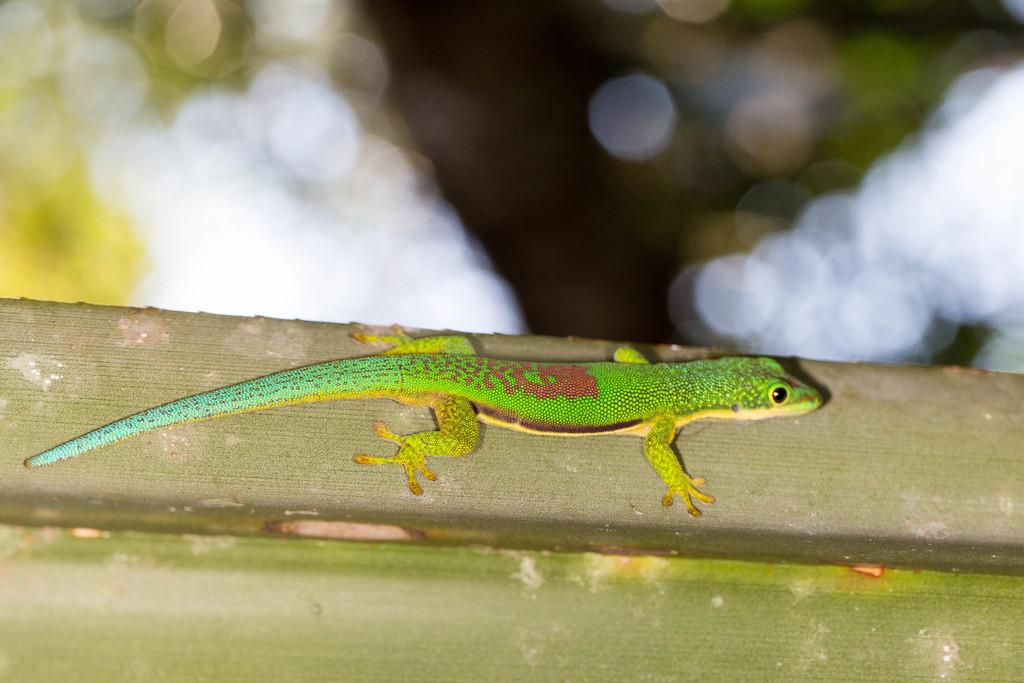What type of animal is in the image? There is a green anole in the image. Where is the green anole located? The green anole is present on a wooden post. What type of company is depicted in the image? There is no company present in the image; it features a green anole on a wooden post. How many people are in the group shown in the image? There are no people or groups present in the image; it features a green anole on a wooden post. 